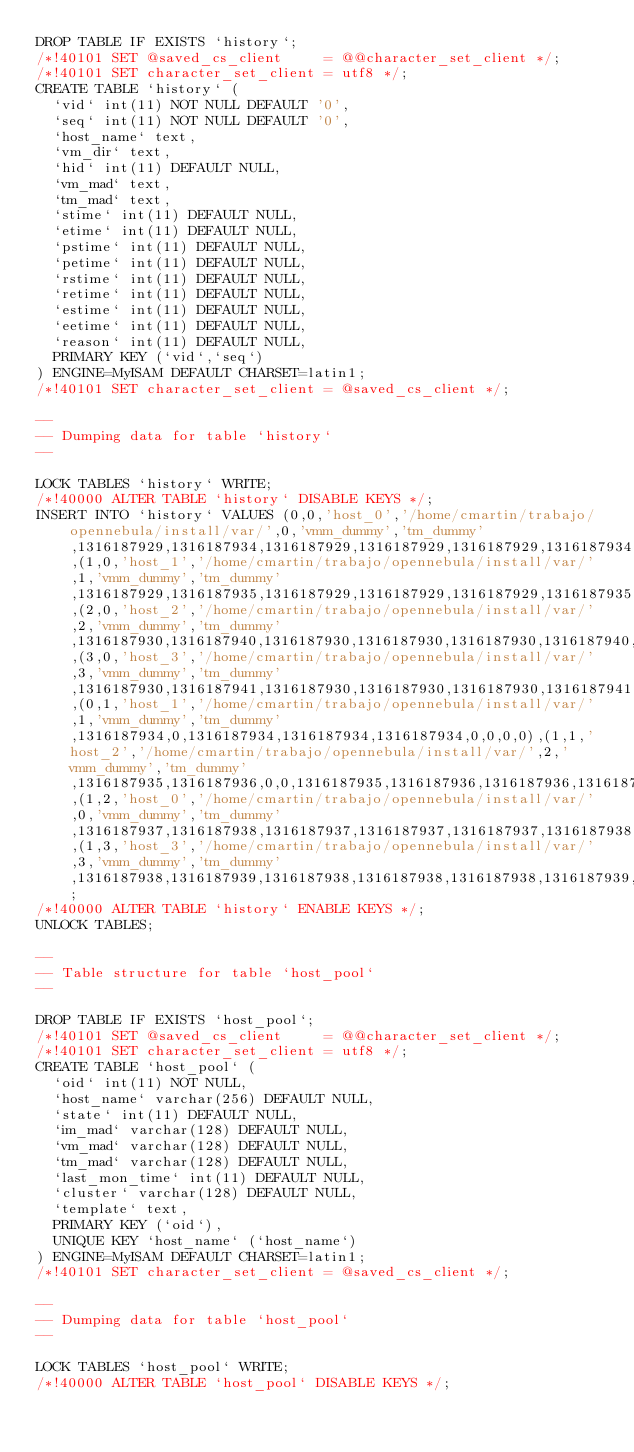Convert code to text. <code><loc_0><loc_0><loc_500><loc_500><_SQL_>DROP TABLE IF EXISTS `history`;
/*!40101 SET @saved_cs_client     = @@character_set_client */;
/*!40101 SET character_set_client = utf8 */;
CREATE TABLE `history` (
  `vid` int(11) NOT NULL DEFAULT '0',
  `seq` int(11) NOT NULL DEFAULT '0',
  `host_name` text,
  `vm_dir` text,
  `hid` int(11) DEFAULT NULL,
  `vm_mad` text,
  `tm_mad` text,
  `stime` int(11) DEFAULT NULL,
  `etime` int(11) DEFAULT NULL,
  `pstime` int(11) DEFAULT NULL,
  `petime` int(11) DEFAULT NULL,
  `rstime` int(11) DEFAULT NULL,
  `retime` int(11) DEFAULT NULL,
  `estime` int(11) DEFAULT NULL,
  `eetime` int(11) DEFAULT NULL,
  `reason` int(11) DEFAULT NULL,
  PRIMARY KEY (`vid`,`seq`)
) ENGINE=MyISAM DEFAULT CHARSET=latin1;
/*!40101 SET character_set_client = @saved_cs_client */;

--
-- Dumping data for table `history`
--

LOCK TABLES `history` WRITE;
/*!40000 ALTER TABLE `history` DISABLE KEYS */;
INSERT INTO `history` VALUES (0,0,'host_0','/home/cmartin/trabajo/opennebula/install/var/',0,'vmm_dummy','tm_dummy',1316187929,1316187934,1316187929,1316187929,1316187929,1316187934,0,0,3),(1,0,'host_1','/home/cmartin/trabajo/opennebula/install/var/',1,'vmm_dummy','tm_dummy',1316187929,1316187935,1316187929,1316187929,1316187929,1316187935,0,0,3),(2,0,'host_2','/home/cmartin/trabajo/opennebula/install/var/',2,'vmm_dummy','tm_dummy',1316187930,1316187940,1316187930,1316187930,1316187930,1316187940,1316187940,1316187940,0),(3,0,'host_3','/home/cmartin/trabajo/opennebula/install/var/',3,'vmm_dummy','tm_dummy',1316187930,1316187941,1316187930,1316187930,1316187930,1316187941,0,0,3),(0,1,'host_1','/home/cmartin/trabajo/opennebula/install/var/',1,'vmm_dummy','tm_dummy',1316187934,0,1316187934,1316187934,1316187934,0,0,0,0),(1,1,'host_2','/home/cmartin/trabajo/opennebula/install/var/',2,'vmm_dummy','tm_dummy',1316187935,1316187936,0,0,1316187935,1316187936,1316187936,1316187936,2),(1,2,'host_0','/home/cmartin/trabajo/opennebula/install/var/',0,'vmm_dummy','tm_dummy',1316187937,1316187938,1316187937,1316187937,1316187937,1316187938,0,0,3),(1,3,'host_3','/home/cmartin/trabajo/opennebula/install/var/',3,'vmm_dummy','tm_dummy',1316187938,1316187939,1316187938,1316187938,1316187938,1316187939,1316187939,1316187939,0);
/*!40000 ALTER TABLE `history` ENABLE KEYS */;
UNLOCK TABLES;

--
-- Table structure for table `host_pool`
--

DROP TABLE IF EXISTS `host_pool`;
/*!40101 SET @saved_cs_client     = @@character_set_client */;
/*!40101 SET character_set_client = utf8 */;
CREATE TABLE `host_pool` (
  `oid` int(11) NOT NULL,
  `host_name` varchar(256) DEFAULT NULL,
  `state` int(11) DEFAULT NULL,
  `im_mad` varchar(128) DEFAULT NULL,
  `vm_mad` varchar(128) DEFAULT NULL,
  `tm_mad` varchar(128) DEFAULT NULL,
  `last_mon_time` int(11) DEFAULT NULL,
  `cluster` varchar(128) DEFAULT NULL,
  `template` text,
  PRIMARY KEY (`oid`),
  UNIQUE KEY `host_name` (`host_name`)
) ENGINE=MyISAM DEFAULT CHARSET=latin1;
/*!40101 SET character_set_client = @saved_cs_client */;

--
-- Dumping data for table `host_pool`
--

LOCK TABLES `host_pool` WRITE;
/*!40000 ALTER TABLE `host_pool` DISABLE KEYS */;</code> 